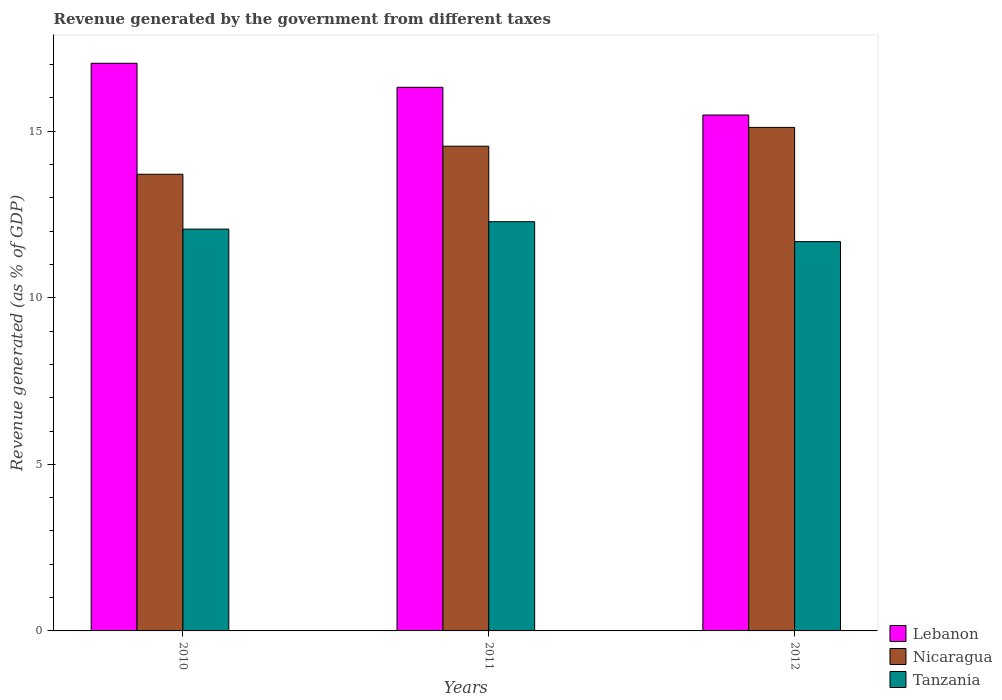How many groups of bars are there?
Provide a short and direct response. 3. Are the number of bars per tick equal to the number of legend labels?
Give a very brief answer. Yes. How many bars are there on the 2nd tick from the left?
Your response must be concise. 3. In how many cases, is the number of bars for a given year not equal to the number of legend labels?
Provide a succinct answer. 0. What is the revenue generated by the government in Nicaragua in 2010?
Provide a short and direct response. 13.71. Across all years, what is the maximum revenue generated by the government in Lebanon?
Give a very brief answer. 17.04. Across all years, what is the minimum revenue generated by the government in Nicaragua?
Provide a succinct answer. 13.71. In which year was the revenue generated by the government in Lebanon maximum?
Provide a short and direct response. 2010. What is the total revenue generated by the government in Tanzania in the graph?
Your response must be concise. 36.03. What is the difference between the revenue generated by the government in Nicaragua in 2010 and that in 2011?
Give a very brief answer. -0.84. What is the difference between the revenue generated by the government in Lebanon in 2011 and the revenue generated by the government in Tanzania in 2010?
Make the answer very short. 4.26. What is the average revenue generated by the government in Lebanon per year?
Provide a succinct answer. 16.28. In the year 2011, what is the difference between the revenue generated by the government in Nicaragua and revenue generated by the government in Tanzania?
Ensure brevity in your answer.  2.27. What is the ratio of the revenue generated by the government in Lebanon in 2010 to that in 2012?
Your answer should be compact. 1.1. Is the revenue generated by the government in Lebanon in 2010 less than that in 2011?
Keep it short and to the point. No. What is the difference between the highest and the second highest revenue generated by the government in Tanzania?
Give a very brief answer. 0.22. What is the difference between the highest and the lowest revenue generated by the government in Tanzania?
Ensure brevity in your answer.  0.6. In how many years, is the revenue generated by the government in Nicaragua greater than the average revenue generated by the government in Nicaragua taken over all years?
Provide a short and direct response. 2. What does the 3rd bar from the left in 2011 represents?
Provide a succinct answer. Tanzania. What does the 2nd bar from the right in 2012 represents?
Offer a very short reply. Nicaragua. Is it the case that in every year, the sum of the revenue generated by the government in Tanzania and revenue generated by the government in Nicaragua is greater than the revenue generated by the government in Lebanon?
Offer a very short reply. Yes. How many bars are there?
Your answer should be very brief. 9. Are all the bars in the graph horizontal?
Your answer should be very brief. No. How many years are there in the graph?
Provide a succinct answer. 3. What is the difference between two consecutive major ticks on the Y-axis?
Provide a short and direct response. 5. Are the values on the major ticks of Y-axis written in scientific E-notation?
Ensure brevity in your answer.  No. Does the graph contain grids?
Your answer should be very brief. No. What is the title of the graph?
Your response must be concise. Revenue generated by the government from different taxes. Does "Middle East & North Africa (all income levels)" appear as one of the legend labels in the graph?
Provide a succinct answer. No. What is the label or title of the X-axis?
Provide a short and direct response. Years. What is the label or title of the Y-axis?
Offer a terse response. Revenue generated (as % of GDP). What is the Revenue generated (as % of GDP) in Lebanon in 2010?
Offer a terse response. 17.04. What is the Revenue generated (as % of GDP) in Nicaragua in 2010?
Make the answer very short. 13.71. What is the Revenue generated (as % of GDP) of Tanzania in 2010?
Offer a terse response. 12.06. What is the Revenue generated (as % of GDP) in Lebanon in 2011?
Keep it short and to the point. 16.32. What is the Revenue generated (as % of GDP) of Nicaragua in 2011?
Make the answer very short. 14.55. What is the Revenue generated (as % of GDP) in Tanzania in 2011?
Your response must be concise. 12.28. What is the Revenue generated (as % of GDP) in Lebanon in 2012?
Your answer should be very brief. 15.48. What is the Revenue generated (as % of GDP) of Nicaragua in 2012?
Ensure brevity in your answer.  15.11. What is the Revenue generated (as % of GDP) in Tanzania in 2012?
Offer a very short reply. 11.68. Across all years, what is the maximum Revenue generated (as % of GDP) in Lebanon?
Offer a terse response. 17.04. Across all years, what is the maximum Revenue generated (as % of GDP) of Nicaragua?
Provide a short and direct response. 15.11. Across all years, what is the maximum Revenue generated (as % of GDP) of Tanzania?
Provide a succinct answer. 12.28. Across all years, what is the minimum Revenue generated (as % of GDP) in Lebanon?
Make the answer very short. 15.48. Across all years, what is the minimum Revenue generated (as % of GDP) in Nicaragua?
Your response must be concise. 13.71. Across all years, what is the minimum Revenue generated (as % of GDP) in Tanzania?
Offer a terse response. 11.68. What is the total Revenue generated (as % of GDP) in Lebanon in the graph?
Provide a succinct answer. 48.84. What is the total Revenue generated (as % of GDP) of Nicaragua in the graph?
Make the answer very short. 43.36. What is the total Revenue generated (as % of GDP) in Tanzania in the graph?
Keep it short and to the point. 36.03. What is the difference between the Revenue generated (as % of GDP) of Lebanon in 2010 and that in 2011?
Provide a short and direct response. 0.72. What is the difference between the Revenue generated (as % of GDP) of Nicaragua in 2010 and that in 2011?
Give a very brief answer. -0.84. What is the difference between the Revenue generated (as % of GDP) in Tanzania in 2010 and that in 2011?
Keep it short and to the point. -0.22. What is the difference between the Revenue generated (as % of GDP) of Lebanon in 2010 and that in 2012?
Make the answer very short. 1.55. What is the difference between the Revenue generated (as % of GDP) in Nicaragua in 2010 and that in 2012?
Your answer should be compact. -1.41. What is the difference between the Revenue generated (as % of GDP) of Tanzania in 2010 and that in 2012?
Ensure brevity in your answer.  0.38. What is the difference between the Revenue generated (as % of GDP) in Lebanon in 2011 and that in 2012?
Ensure brevity in your answer.  0.83. What is the difference between the Revenue generated (as % of GDP) of Nicaragua in 2011 and that in 2012?
Keep it short and to the point. -0.56. What is the difference between the Revenue generated (as % of GDP) of Tanzania in 2011 and that in 2012?
Give a very brief answer. 0.6. What is the difference between the Revenue generated (as % of GDP) in Lebanon in 2010 and the Revenue generated (as % of GDP) in Nicaragua in 2011?
Provide a short and direct response. 2.49. What is the difference between the Revenue generated (as % of GDP) in Lebanon in 2010 and the Revenue generated (as % of GDP) in Tanzania in 2011?
Offer a very short reply. 4.75. What is the difference between the Revenue generated (as % of GDP) in Nicaragua in 2010 and the Revenue generated (as % of GDP) in Tanzania in 2011?
Provide a succinct answer. 1.42. What is the difference between the Revenue generated (as % of GDP) of Lebanon in 2010 and the Revenue generated (as % of GDP) of Nicaragua in 2012?
Provide a succinct answer. 1.92. What is the difference between the Revenue generated (as % of GDP) of Lebanon in 2010 and the Revenue generated (as % of GDP) of Tanzania in 2012?
Make the answer very short. 5.35. What is the difference between the Revenue generated (as % of GDP) of Nicaragua in 2010 and the Revenue generated (as % of GDP) of Tanzania in 2012?
Your response must be concise. 2.02. What is the difference between the Revenue generated (as % of GDP) of Lebanon in 2011 and the Revenue generated (as % of GDP) of Nicaragua in 2012?
Give a very brief answer. 1.2. What is the difference between the Revenue generated (as % of GDP) in Lebanon in 2011 and the Revenue generated (as % of GDP) in Tanzania in 2012?
Your answer should be very brief. 4.63. What is the difference between the Revenue generated (as % of GDP) of Nicaragua in 2011 and the Revenue generated (as % of GDP) of Tanzania in 2012?
Ensure brevity in your answer.  2.86. What is the average Revenue generated (as % of GDP) in Lebanon per year?
Make the answer very short. 16.28. What is the average Revenue generated (as % of GDP) in Nicaragua per year?
Keep it short and to the point. 14.46. What is the average Revenue generated (as % of GDP) in Tanzania per year?
Your answer should be very brief. 12.01. In the year 2010, what is the difference between the Revenue generated (as % of GDP) of Lebanon and Revenue generated (as % of GDP) of Nicaragua?
Give a very brief answer. 3.33. In the year 2010, what is the difference between the Revenue generated (as % of GDP) of Lebanon and Revenue generated (as % of GDP) of Tanzania?
Ensure brevity in your answer.  4.98. In the year 2010, what is the difference between the Revenue generated (as % of GDP) in Nicaragua and Revenue generated (as % of GDP) in Tanzania?
Your response must be concise. 1.65. In the year 2011, what is the difference between the Revenue generated (as % of GDP) of Lebanon and Revenue generated (as % of GDP) of Nicaragua?
Make the answer very short. 1.77. In the year 2011, what is the difference between the Revenue generated (as % of GDP) of Lebanon and Revenue generated (as % of GDP) of Tanzania?
Your answer should be very brief. 4.03. In the year 2011, what is the difference between the Revenue generated (as % of GDP) of Nicaragua and Revenue generated (as % of GDP) of Tanzania?
Provide a succinct answer. 2.27. In the year 2012, what is the difference between the Revenue generated (as % of GDP) of Lebanon and Revenue generated (as % of GDP) of Nicaragua?
Give a very brief answer. 0.37. In the year 2012, what is the difference between the Revenue generated (as % of GDP) of Lebanon and Revenue generated (as % of GDP) of Tanzania?
Give a very brief answer. 3.8. In the year 2012, what is the difference between the Revenue generated (as % of GDP) in Nicaragua and Revenue generated (as % of GDP) in Tanzania?
Make the answer very short. 3.43. What is the ratio of the Revenue generated (as % of GDP) in Lebanon in 2010 to that in 2011?
Your answer should be very brief. 1.04. What is the ratio of the Revenue generated (as % of GDP) of Nicaragua in 2010 to that in 2011?
Your answer should be compact. 0.94. What is the ratio of the Revenue generated (as % of GDP) of Tanzania in 2010 to that in 2011?
Give a very brief answer. 0.98. What is the ratio of the Revenue generated (as % of GDP) of Lebanon in 2010 to that in 2012?
Offer a very short reply. 1.1. What is the ratio of the Revenue generated (as % of GDP) of Nicaragua in 2010 to that in 2012?
Offer a very short reply. 0.91. What is the ratio of the Revenue generated (as % of GDP) in Tanzania in 2010 to that in 2012?
Your response must be concise. 1.03. What is the ratio of the Revenue generated (as % of GDP) in Lebanon in 2011 to that in 2012?
Provide a succinct answer. 1.05. What is the ratio of the Revenue generated (as % of GDP) of Nicaragua in 2011 to that in 2012?
Provide a succinct answer. 0.96. What is the ratio of the Revenue generated (as % of GDP) of Tanzania in 2011 to that in 2012?
Your answer should be compact. 1.05. What is the difference between the highest and the second highest Revenue generated (as % of GDP) of Lebanon?
Provide a short and direct response. 0.72. What is the difference between the highest and the second highest Revenue generated (as % of GDP) in Nicaragua?
Give a very brief answer. 0.56. What is the difference between the highest and the second highest Revenue generated (as % of GDP) of Tanzania?
Ensure brevity in your answer.  0.22. What is the difference between the highest and the lowest Revenue generated (as % of GDP) of Lebanon?
Offer a terse response. 1.55. What is the difference between the highest and the lowest Revenue generated (as % of GDP) in Nicaragua?
Offer a terse response. 1.41. What is the difference between the highest and the lowest Revenue generated (as % of GDP) of Tanzania?
Provide a succinct answer. 0.6. 